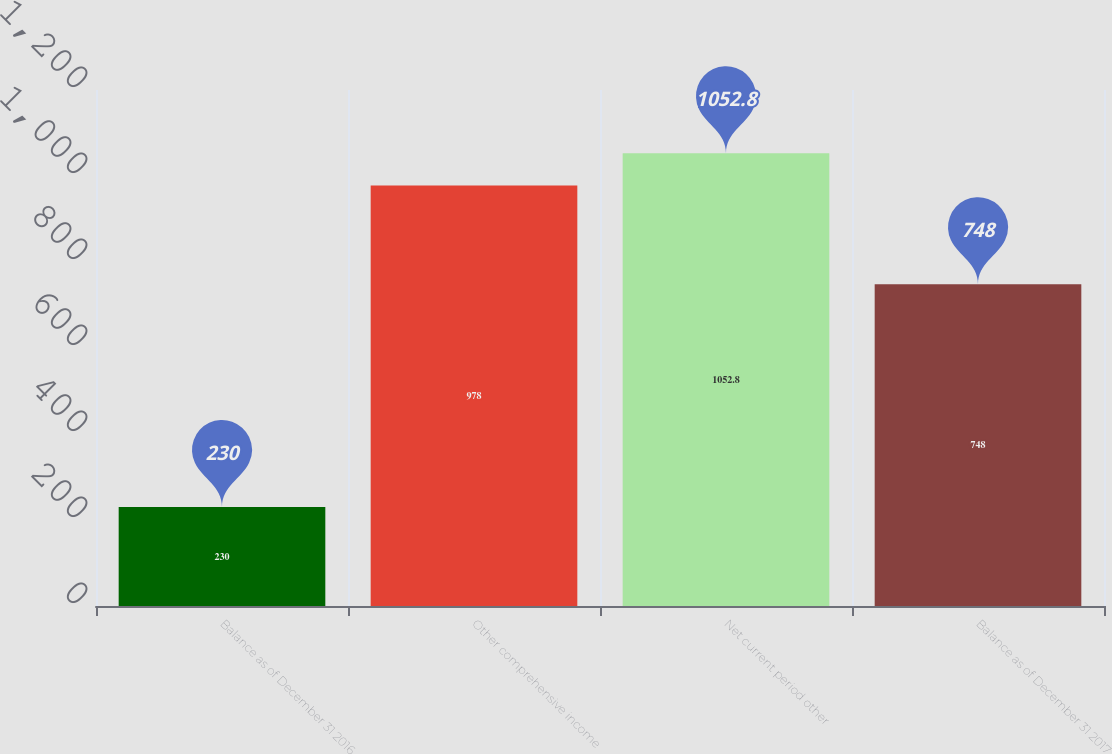Convert chart to OTSL. <chart><loc_0><loc_0><loc_500><loc_500><bar_chart><fcel>Balance as of December 31 2016<fcel>Other comprehensive income<fcel>Net current period other<fcel>Balance as of December 31 2017<nl><fcel>230<fcel>978<fcel>1052.8<fcel>748<nl></chart> 